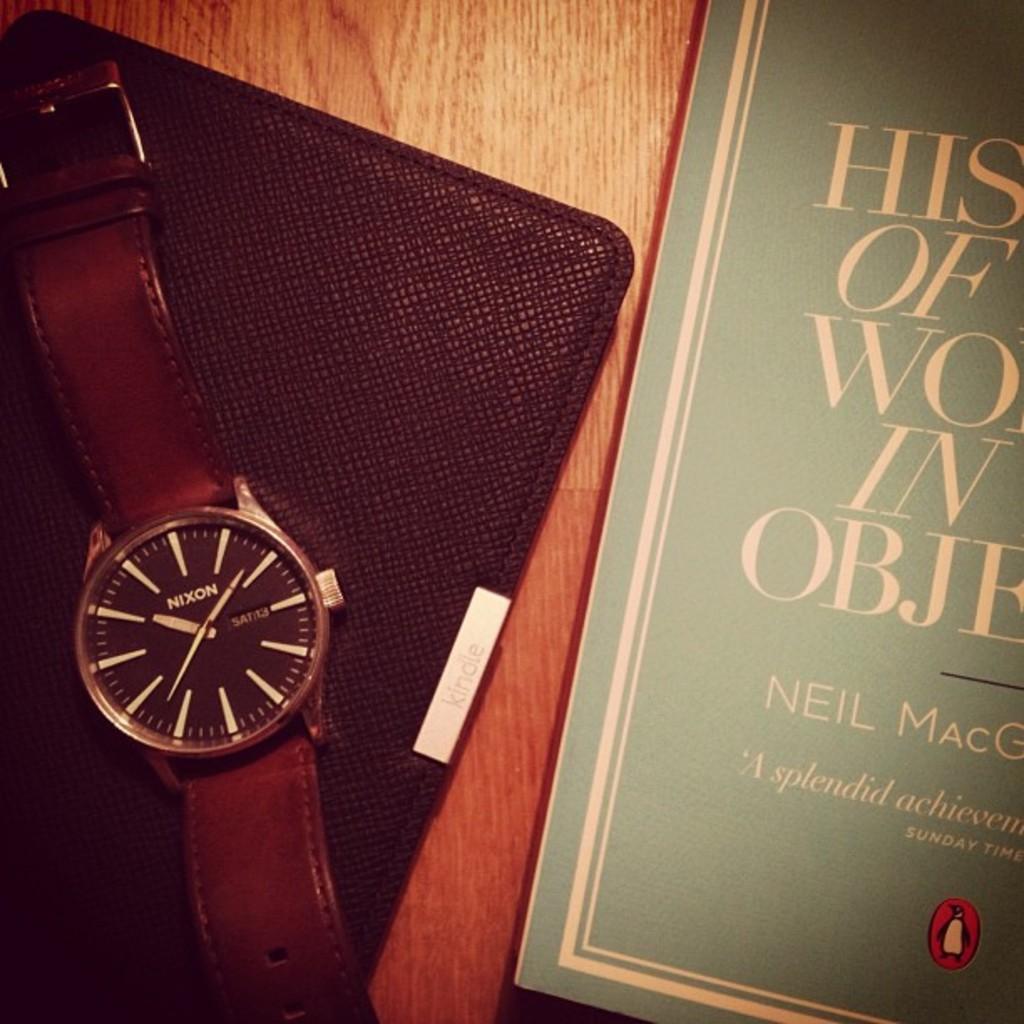What's the first letter in the title of the book?
Provide a succinct answer. H. What is the first name of the author?
Give a very brief answer. Neil. 